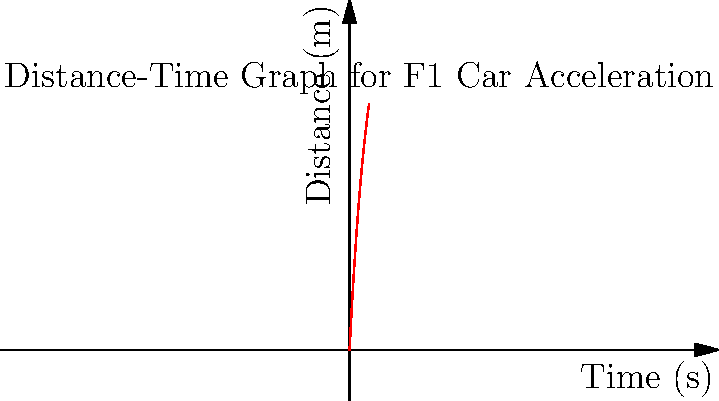A Formula 1 car, reminiscent of Juan Pablo Montoya's racing days, accelerates from rest to 100 km/h. The distance-time graph of this acceleration is shown above. Using the graph, determine the time taken for the car to reach a speed of 100 km/h (27.78 m/s). To solve this problem, we need to follow these steps:

1) The graph shows distance against time. We need to find the time at which the car's speed reaches 100 km/h (27.78 m/s).

2) Speed is the rate of change of distance with respect to time, which is represented by the slope of the distance-time graph.

3) We're looking for the point where the slope of the tangent line to the curve is 27.78 m/s.

4) From the graph, we can see that the curve starts to level off around 4-5 seconds.

5) The equation of the curve appears to be of the form:

   $$s(t) = 100(1-e^{-0.2t})$$

   where $s$ is distance in meters and $t$ is time in seconds.

6) To find the speed, we need to differentiate this equation:

   $$v(t) = \frac{ds}{dt} = 100(0.2e^{-0.2t}) = 20e^{-0.2t}$$

7) We want to find $t$ when $v(t) = 27.78$:

   $$27.78 = 20e^{-0.2t}$$

8) Solving for $t$:

   $$e^{-0.2t} = \frac{27.78}{20} = 1.389$$
   $$-0.2t = \ln(1.389) = 0.329$$
   $$t = -\frac{0.329}{0.2} = 1.645$$

Therefore, the car reaches 100 km/h after approximately 1.65 seconds.
Answer: 1.65 seconds 